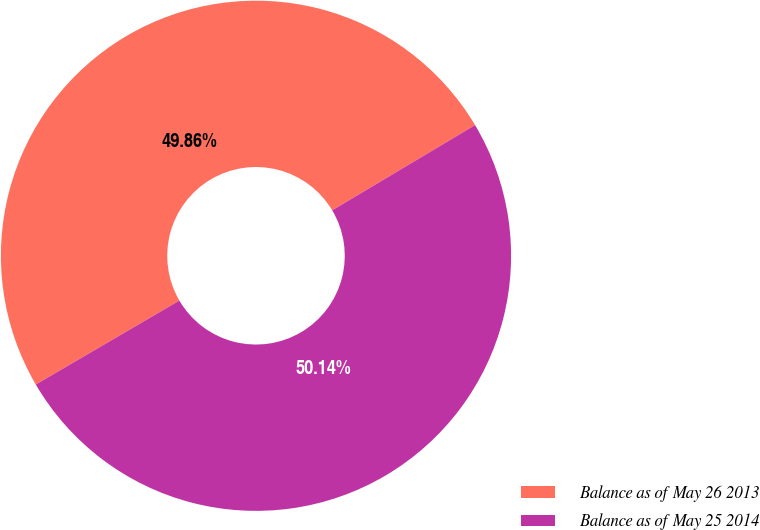Convert chart to OTSL. <chart><loc_0><loc_0><loc_500><loc_500><pie_chart><fcel>Balance as of May 26 2013<fcel>Balance as of May 25 2014<nl><fcel>49.86%<fcel>50.14%<nl></chart> 